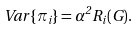<formula> <loc_0><loc_0><loc_500><loc_500>V a r \left \{ \pi _ { i } \right \} = \alpha ^ { 2 } R _ { i } ( G ) .</formula> 